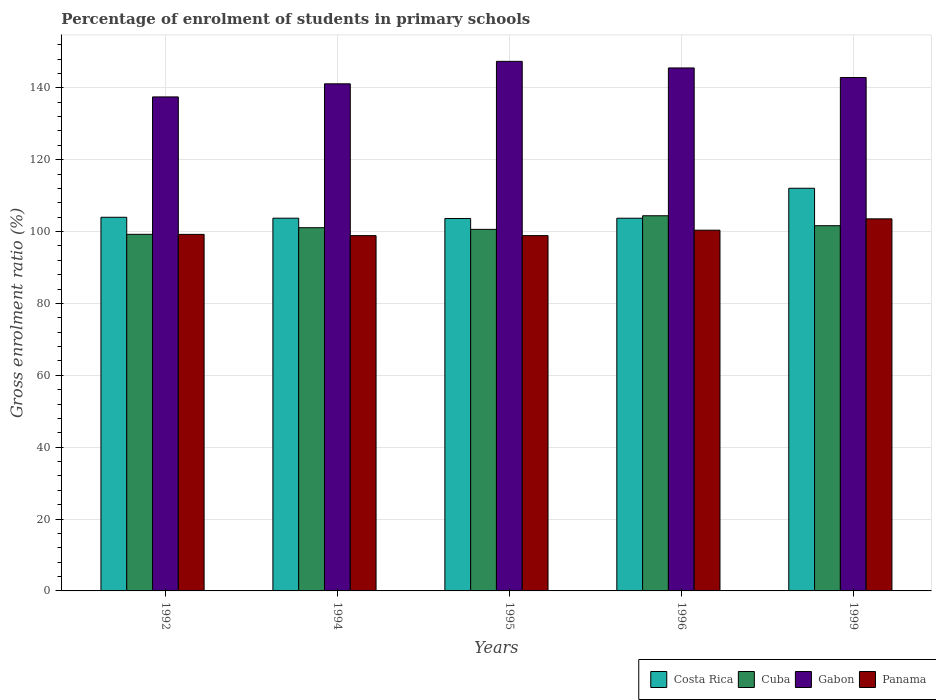How many groups of bars are there?
Give a very brief answer. 5. Are the number of bars per tick equal to the number of legend labels?
Your answer should be very brief. Yes. Are the number of bars on each tick of the X-axis equal?
Offer a terse response. Yes. How many bars are there on the 3rd tick from the left?
Make the answer very short. 4. What is the label of the 5th group of bars from the left?
Offer a very short reply. 1999. In how many cases, is the number of bars for a given year not equal to the number of legend labels?
Ensure brevity in your answer.  0. What is the percentage of students enrolled in primary schools in Costa Rica in 1996?
Keep it short and to the point. 103.72. Across all years, what is the maximum percentage of students enrolled in primary schools in Cuba?
Ensure brevity in your answer.  104.41. Across all years, what is the minimum percentage of students enrolled in primary schools in Panama?
Offer a terse response. 98.87. In which year was the percentage of students enrolled in primary schools in Panama maximum?
Your response must be concise. 1999. In which year was the percentage of students enrolled in primary schools in Panama minimum?
Give a very brief answer. 1994. What is the total percentage of students enrolled in primary schools in Costa Rica in the graph?
Make the answer very short. 527.13. What is the difference between the percentage of students enrolled in primary schools in Panama in 1994 and that in 1999?
Keep it short and to the point. -4.67. What is the difference between the percentage of students enrolled in primary schools in Cuba in 1996 and the percentage of students enrolled in primary schools in Costa Rica in 1995?
Your answer should be compact. 0.76. What is the average percentage of students enrolled in primary schools in Gabon per year?
Your answer should be very brief. 142.88. In the year 1995, what is the difference between the percentage of students enrolled in primary schools in Gabon and percentage of students enrolled in primary schools in Cuba?
Your answer should be very brief. 46.76. In how many years, is the percentage of students enrolled in primary schools in Costa Rica greater than 36 %?
Your answer should be compact. 5. What is the ratio of the percentage of students enrolled in primary schools in Panama in 1992 to that in 1999?
Your response must be concise. 0.96. What is the difference between the highest and the second highest percentage of students enrolled in primary schools in Cuba?
Provide a succinct answer. 2.77. What is the difference between the highest and the lowest percentage of students enrolled in primary schools in Gabon?
Keep it short and to the point. 9.9. Is the sum of the percentage of students enrolled in primary schools in Cuba in 1992 and 1996 greater than the maximum percentage of students enrolled in primary schools in Costa Rica across all years?
Your answer should be very brief. Yes. What does the 4th bar from the left in 1995 represents?
Offer a terse response. Panama. What does the 1st bar from the right in 1994 represents?
Provide a short and direct response. Panama. How many bars are there?
Your answer should be very brief. 20. Does the graph contain any zero values?
Offer a very short reply. No. Where does the legend appear in the graph?
Make the answer very short. Bottom right. How are the legend labels stacked?
Make the answer very short. Horizontal. What is the title of the graph?
Provide a succinct answer. Percentage of enrolment of students in primary schools. What is the label or title of the X-axis?
Keep it short and to the point. Years. What is the Gross enrolment ratio (%) in Costa Rica in 1992?
Offer a very short reply. 103.98. What is the Gross enrolment ratio (%) of Cuba in 1992?
Offer a terse response. 99.24. What is the Gross enrolment ratio (%) in Gabon in 1992?
Your answer should be compact. 137.48. What is the Gross enrolment ratio (%) of Panama in 1992?
Your response must be concise. 99.22. What is the Gross enrolment ratio (%) in Costa Rica in 1994?
Provide a short and direct response. 103.73. What is the Gross enrolment ratio (%) in Cuba in 1994?
Your answer should be very brief. 101.08. What is the Gross enrolment ratio (%) in Gabon in 1994?
Offer a very short reply. 141.12. What is the Gross enrolment ratio (%) of Panama in 1994?
Give a very brief answer. 98.87. What is the Gross enrolment ratio (%) in Costa Rica in 1995?
Your answer should be very brief. 103.64. What is the Gross enrolment ratio (%) of Cuba in 1995?
Your answer should be compact. 100.62. What is the Gross enrolment ratio (%) of Gabon in 1995?
Provide a succinct answer. 147.37. What is the Gross enrolment ratio (%) of Panama in 1995?
Provide a succinct answer. 98.88. What is the Gross enrolment ratio (%) of Costa Rica in 1996?
Give a very brief answer. 103.72. What is the Gross enrolment ratio (%) in Cuba in 1996?
Ensure brevity in your answer.  104.41. What is the Gross enrolment ratio (%) of Gabon in 1996?
Your response must be concise. 145.54. What is the Gross enrolment ratio (%) in Panama in 1996?
Your answer should be very brief. 100.39. What is the Gross enrolment ratio (%) of Costa Rica in 1999?
Give a very brief answer. 112.06. What is the Gross enrolment ratio (%) of Cuba in 1999?
Your answer should be compact. 101.63. What is the Gross enrolment ratio (%) in Gabon in 1999?
Keep it short and to the point. 142.87. What is the Gross enrolment ratio (%) in Panama in 1999?
Your answer should be compact. 103.54. Across all years, what is the maximum Gross enrolment ratio (%) in Costa Rica?
Keep it short and to the point. 112.06. Across all years, what is the maximum Gross enrolment ratio (%) in Cuba?
Your answer should be very brief. 104.41. Across all years, what is the maximum Gross enrolment ratio (%) of Gabon?
Your answer should be very brief. 147.37. Across all years, what is the maximum Gross enrolment ratio (%) of Panama?
Give a very brief answer. 103.54. Across all years, what is the minimum Gross enrolment ratio (%) of Costa Rica?
Your answer should be very brief. 103.64. Across all years, what is the minimum Gross enrolment ratio (%) in Cuba?
Your answer should be very brief. 99.24. Across all years, what is the minimum Gross enrolment ratio (%) of Gabon?
Offer a terse response. 137.48. Across all years, what is the minimum Gross enrolment ratio (%) in Panama?
Your response must be concise. 98.87. What is the total Gross enrolment ratio (%) in Costa Rica in the graph?
Offer a very short reply. 527.13. What is the total Gross enrolment ratio (%) in Cuba in the graph?
Your answer should be very brief. 506.97. What is the total Gross enrolment ratio (%) of Gabon in the graph?
Provide a succinct answer. 714.39. What is the total Gross enrolment ratio (%) in Panama in the graph?
Your answer should be compact. 500.91. What is the difference between the Gross enrolment ratio (%) of Costa Rica in 1992 and that in 1994?
Your response must be concise. 0.26. What is the difference between the Gross enrolment ratio (%) in Cuba in 1992 and that in 1994?
Provide a short and direct response. -1.84. What is the difference between the Gross enrolment ratio (%) in Gabon in 1992 and that in 1994?
Your answer should be compact. -3.65. What is the difference between the Gross enrolment ratio (%) in Panama in 1992 and that in 1994?
Provide a short and direct response. 0.35. What is the difference between the Gross enrolment ratio (%) of Costa Rica in 1992 and that in 1995?
Provide a succinct answer. 0.34. What is the difference between the Gross enrolment ratio (%) in Cuba in 1992 and that in 1995?
Give a very brief answer. -1.38. What is the difference between the Gross enrolment ratio (%) in Gabon in 1992 and that in 1995?
Your response must be concise. -9.9. What is the difference between the Gross enrolment ratio (%) in Panama in 1992 and that in 1995?
Offer a very short reply. 0.34. What is the difference between the Gross enrolment ratio (%) of Costa Rica in 1992 and that in 1996?
Your response must be concise. 0.27. What is the difference between the Gross enrolment ratio (%) in Cuba in 1992 and that in 1996?
Make the answer very short. -5.17. What is the difference between the Gross enrolment ratio (%) in Gabon in 1992 and that in 1996?
Give a very brief answer. -8.06. What is the difference between the Gross enrolment ratio (%) in Panama in 1992 and that in 1996?
Keep it short and to the point. -1.17. What is the difference between the Gross enrolment ratio (%) of Costa Rica in 1992 and that in 1999?
Offer a very short reply. -8.07. What is the difference between the Gross enrolment ratio (%) of Cuba in 1992 and that in 1999?
Your answer should be compact. -2.4. What is the difference between the Gross enrolment ratio (%) in Gabon in 1992 and that in 1999?
Ensure brevity in your answer.  -5.4. What is the difference between the Gross enrolment ratio (%) of Panama in 1992 and that in 1999?
Ensure brevity in your answer.  -4.32. What is the difference between the Gross enrolment ratio (%) in Costa Rica in 1994 and that in 1995?
Offer a terse response. 0.08. What is the difference between the Gross enrolment ratio (%) of Cuba in 1994 and that in 1995?
Give a very brief answer. 0.46. What is the difference between the Gross enrolment ratio (%) of Gabon in 1994 and that in 1995?
Provide a succinct answer. -6.25. What is the difference between the Gross enrolment ratio (%) in Panama in 1994 and that in 1995?
Make the answer very short. -0.01. What is the difference between the Gross enrolment ratio (%) of Costa Rica in 1994 and that in 1996?
Offer a very short reply. 0.01. What is the difference between the Gross enrolment ratio (%) of Cuba in 1994 and that in 1996?
Your answer should be compact. -3.33. What is the difference between the Gross enrolment ratio (%) of Gabon in 1994 and that in 1996?
Your answer should be very brief. -4.42. What is the difference between the Gross enrolment ratio (%) in Panama in 1994 and that in 1996?
Make the answer very short. -1.51. What is the difference between the Gross enrolment ratio (%) of Costa Rica in 1994 and that in 1999?
Offer a very short reply. -8.33. What is the difference between the Gross enrolment ratio (%) in Cuba in 1994 and that in 1999?
Ensure brevity in your answer.  -0.56. What is the difference between the Gross enrolment ratio (%) of Gabon in 1994 and that in 1999?
Your answer should be very brief. -1.75. What is the difference between the Gross enrolment ratio (%) in Panama in 1994 and that in 1999?
Make the answer very short. -4.67. What is the difference between the Gross enrolment ratio (%) in Costa Rica in 1995 and that in 1996?
Keep it short and to the point. -0.08. What is the difference between the Gross enrolment ratio (%) of Cuba in 1995 and that in 1996?
Give a very brief answer. -3.79. What is the difference between the Gross enrolment ratio (%) of Gabon in 1995 and that in 1996?
Give a very brief answer. 1.83. What is the difference between the Gross enrolment ratio (%) of Panama in 1995 and that in 1996?
Your answer should be compact. -1.51. What is the difference between the Gross enrolment ratio (%) of Costa Rica in 1995 and that in 1999?
Your answer should be compact. -8.42. What is the difference between the Gross enrolment ratio (%) in Cuba in 1995 and that in 1999?
Offer a terse response. -1.02. What is the difference between the Gross enrolment ratio (%) of Gabon in 1995 and that in 1999?
Provide a short and direct response. 4.5. What is the difference between the Gross enrolment ratio (%) of Panama in 1995 and that in 1999?
Offer a terse response. -4.66. What is the difference between the Gross enrolment ratio (%) of Costa Rica in 1996 and that in 1999?
Offer a terse response. -8.34. What is the difference between the Gross enrolment ratio (%) in Cuba in 1996 and that in 1999?
Your response must be concise. 2.77. What is the difference between the Gross enrolment ratio (%) in Gabon in 1996 and that in 1999?
Give a very brief answer. 2.67. What is the difference between the Gross enrolment ratio (%) in Panama in 1996 and that in 1999?
Your answer should be compact. -3.15. What is the difference between the Gross enrolment ratio (%) of Costa Rica in 1992 and the Gross enrolment ratio (%) of Cuba in 1994?
Offer a very short reply. 2.91. What is the difference between the Gross enrolment ratio (%) of Costa Rica in 1992 and the Gross enrolment ratio (%) of Gabon in 1994?
Your answer should be very brief. -37.14. What is the difference between the Gross enrolment ratio (%) in Costa Rica in 1992 and the Gross enrolment ratio (%) in Panama in 1994?
Offer a terse response. 5.11. What is the difference between the Gross enrolment ratio (%) of Cuba in 1992 and the Gross enrolment ratio (%) of Gabon in 1994?
Offer a terse response. -41.89. What is the difference between the Gross enrolment ratio (%) in Cuba in 1992 and the Gross enrolment ratio (%) in Panama in 1994?
Your answer should be compact. 0.36. What is the difference between the Gross enrolment ratio (%) in Gabon in 1992 and the Gross enrolment ratio (%) in Panama in 1994?
Make the answer very short. 38.6. What is the difference between the Gross enrolment ratio (%) in Costa Rica in 1992 and the Gross enrolment ratio (%) in Cuba in 1995?
Make the answer very short. 3.37. What is the difference between the Gross enrolment ratio (%) of Costa Rica in 1992 and the Gross enrolment ratio (%) of Gabon in 1995?
Your answer should be compact. -43.39. What is the difference between the Gross enrolment ratio (%) in Costa Rica in 1992 and the Gross enrolment ratio (%) in Panama in 1995?
Offer a very short reply. 5.1. What is the difference between the Gross enrolment ratio (%) of Cuba in 1992 and the Gross enrolment ratio (%) of Gabon in 1995?
Your answer should be very brief. -48.14. What is the difference between the Gross enrolment ratio (%) of Cuba in 1992 and the Gross enrolment ratio (%) of Panama in 1995?
Ensure brevity in your answer.  0.36. What is the difference between the Gross enrolment ratio (%) of Gabon in 1992 and the Gross enrolment ratio (%) of Panama in 1995?
Your response must be concise. 38.6. What is the difference between the Gross enrolment ratio (%) of Costa Rica in 1992 and the Gross enrolment ratio (%) of Cuba in 1996?
Your answer should be compact. -0.42. What is the difference between the Gross enrolment ratio (%) in Costa Rica in 1992 and the Gross enrolment ratio (%) in Gabon in 1996?
Offer a terse response. -41.56. What is the difference between the Gross enrolment ratio (%) in Costa Rica in 1992 and the Gross enrolment ratio (%) in Panama in 1996?
Offer a terse response. 3.6. What is the difference between the Gross enrolment ratio (%) of Cuba in 1992 and the Gross enrolment ratio (%) of Gabon in 1996?
Provide a succinct answer. -46.3. What is the difference between the Gross enrolment ratio (%) in Cuba in 1992 and the Gross enrolment ratio (%) in Panama in 1996?
Offer a terse response. -1.15. What is the difference between the Gross enrolment ratio (%) of Gabon in 1992 and the Gross enrolment ratio (%) of Panama in 1996?
Offer a terse response. 37.09. What is the difference between the Gross enrolment ratio (%) of Costa Rica in 1992 and the Gross enrolment ratio (%) of Cuba in 1999?
Ensure brevity in your answer.  2.35. What is the difference between the Gross enrolment ratio (%) in Costa Rica in 1992 and the Gross enrolment ratio (%) in Gabon in 1999?
Give a very brief answer. -38.89. What is the difference between the Gross enrolment ratio (%) in Costa Rica in 1992 and the Gross enrolment ratio (%) in Panama in 1999?
Offer a terse response. 0.44. What is the difference between the Gross enrolment ratio (%) in Cuba in 1992 and the Gross enrolment ratio (%) in Gabon in 1999?
Your response must be concise. -43.64. What is the difference between the Gross enrolment ratio (%) in Cuba in 1992 and the Gross enrolment ratio (%) in Panama in 1999?
Offer a very short reply. -4.3. What is the difference between the Gross enrolment ratio (%) in Gabon in 1992 and the Gross enrolment ratio (%) in Panama in 1999?
Offer a very short reply. 33.93. What is the difference between the Gross enrolment ratio (%) in Costa Rica in 1994 and the Gross enrolment ratio (%) in Cuba in 1995?
Provide a succinct answer. 3.11. What is the difference between the Gross enrolment ratio (%) of Costa Rica in 1994 and the Gross enrolment ratio (%) of Gabon in 1995?
Your response must be concise. -43.65. What is the difference between the Gross enrolment ratio (%) in Costa Rica in 1994 and the Gross enrolment ratio (%) in Panama in 1995?
Your answer should be very brief. 4.85. What is the difference between the Gross enrolment ratio (%) of Cuba in 1994 and the Gross enrolment ratio (%) of Gabon in 1995?
Ensure brevity in your answer.  -46.3. What is the difference between the Gross enrolment ratio (%) in Cuba in 1994 and the Gross enrolment ratio (%) in Panama in 1995?
Provide a short and direct response. 2.2. What is the difference between the Gross enrolment ratio (%) in Gabon in 1994 and the Gross enrolment ratio (%) in Panama in 1995?
Your response must be concise. 42.24. What is the difference between the Gross enrolment ratio (%) of Costa Rica in 1994 and the Gross enrolment ratio (%) of Cuba in 1996?
Give a very brief answer. -0.68. What is the difference between the Gross enrolment ratio (%) in Costa Rica in 1994 and the Gross enrolment ratio (%) in Gabon in 1996?
Offer a very short reply. -41.81. What is the difference between the Gross enrolment ratio (%) of Costa Rica in 1994 and the Gross enrolment ratio (%) of Panama in 1996?
Make the answer very short. 3.34. What is the difference between the Gross enrolment ratio (%) in Cuba in 1994 and the Gross enrolment ratio (%) in Gabon in 1996?
Offer a very short reply. -44.46. What is the difference between the Gross enrolment ratio (%) of Cuba in 1994 and the Gross enrolment ratio (%) of Panama in 1996?
Ensure brevity in your answer.  0.69. What is the difference between the Gross enrolment ratio (%) of Gabon in 1994 and the Gross enrolment ratio (%) of Panama in 1996?
Offer a very short reply. 40.73. What is the difference between the Gross enrolment ratio (%) in Costa Rica in 1994 and the Gross enrolment ratio (%) in Cuba in 1999?
Provide a succinct answer. 2.09. What is the difference between the Gross enrolment ratio (%) of Costa Rica in 1994 and the Gross enrolment ratio (%) of Gabon in 1999?
Keep it short and to the point. -39.15. What is the difference between the Gross enrolment ratio (%) in Costa Rica in 1994 and the Gross enrolment ratio (%) in Panama in 1999?
Ensure brevity in your answer.  0.18. What is the difference between the Gross enrolment ratio (%) of Cuba in 1994 and the Gross enrolment ratio (%) of Gabon in 1999?
Your answer should be compact. -41.8. What is the difference between the Gross enrolment ratio (%) in Cuba in 1994 and the Gross enrolment ratio (%) in Panama in 1999?
Offer a terse response. -2.47. What is the difference between the Gross enrolment ratio (%) in Gabon in 1994 and the Gross enrolment ratio (%) in Panama in 1999?
Offer a very short reply. 37.58. What is the difference between the Gross enrolment ratio (%) in Costa Rica in 1995 and the Gross enrolment ratio (%) in Cuba in 1996?
Offer a very short reply. -0.76. What is the difference between the Gross enrolment ratio (%) of Costa Rica in 1995 and the Gross enrolment ratio (%) of Gabon in 1996?
Your answer should be very brief. -41.9. What is the difference between the Gross enrolment ratio (%) in Costa Rica in 1995 and the Gross enrolment ratio (%) in Panama in 1996?
Ensure brevity in your answer.  3.25. What is the difference between the Gross enrolment ratio (%) in Cuba in 1995 and the Gross enrolment ratio (%) in Gabon in 1996?
Provide a succinct answer. -44.92. What is the difference between the Gross enrolment ratio (%) of Cuba in 1995 and the Gross enrolment ratio (%) of Panama in 1996?
Offer a very short reply. 0.23. What is the difference between the Gross enrolment ratio (%) in Gabon in 1995 and the Gross enrolment ratio (%) in Panama in 1996?
Your answer should be very brief. 46.99. What is the difference between the Gross enrolment ratio (%) in Costa Rica in 1995 and the Gross enrolment ratio (%) in Cuba in 1999?
Provide a short and direct response. 2.01. What is the difference between the Gross enrolment ratio (%) of Costa Rica in 1995 and the Gross enrolment ratio (%) of Gabon in 1999?
Your response must be concise. -39.23. What is the difference between the Gross enrolment ratio (%) of Cuba in 1995 and the Gross enrolment ratio (%) of Gabon in 1999?
Provide a succinct answer. -42.26. What is the difference between the Gross enrolment ratio (%) in Cuba in 1995 and the Gross enrolment ratio (%) in Panama in 1999?
Your answer should be compact. -2.92. What is the difference between the Gross enrolment ratio (%) in Gabon in 1995 and the Gross enrolment ratio (%) in Panama in 1999?
Offer a terse response. 43.83. What is the difference between the Gross enrolment ratio (%) in Costa Rica in 1996 and the Gross enrolment ratio (%) in Cuba in 1999?
Offer a terse response. 2.09. What is the difference between the Gross enrolment ratio (%) of Costa Rica in 1996 and the Gross enrolment ratio (%) of Gabon in 1999?
Make the answer very short. -39.16. What is the difference between the Gross enrolment ratio (%) in Costa Rica in 1996 and the Gross enrolment ratio (%) in Panama in 1999?
Make the answer very short. 0.18. What is the difference between the Gross enrolment ratio (%) in Cuba in 1996 and the Gross enrolment ratio (%) in Gabon in 1999?
Ensure brevity in your answer.  -38.47. What is the difference between the Gross enrolment ratio (%) in Cuba in 1996 and the Gross enrolment ratio (%) in Panama in 1999?
Offer a terse response. 0.86. What is the difference between the Gross enrolment ratio (%) in Gabon in 1996 and the Gross enrolment ratio (%) in Panama in 1999?
Your answer should be very brief. 42. What is the average Gross enrolment ratio (%) of Costa Rica per year?
Provide a short and direct response. 105.43. What is the average Gross enrolment ratio (%) of Cuba per year?
Your response must be concise. 101.39. What is the average Gross enrolment ratio (%) in Gabon per year?
Offer a very short reply. 142.88. What is the average Gross enrolment ratio (%) of Panama per year?
Offer a terse response. 100.18. In the year 1992, what is the difference between the Gross enrolment ratio (%) of Costa Rica and Gross enrolment ratio (%) of Cuba?
Give a very brief answer. 4.75. In the year 1992, what is the difference between the Gross enrolment ratio (%) in Costa Rica and Gross enrolment ratio (%) in Gabon?
Give a very brief answer. -33.49. In the year 1992, what is the difference between the Gross enrolment ratio (%) in Costa Rica and Gross enrolment ratio (%) in Panama?
Your answer should be compact. 4.76. In the year 1992, what is the difference between the Gross enrolment ratio (%) in Cuba and Gross enrolment ratio (%) in Gabon?
Keep it short and to the point. -38.24. In the year 1992, what is the difference between the Gross enrolment ratio (%) of Cuba and Gross enrolment ratio (%) of Panama?
Provide a succinct answer. 0.02. In the year 1992, what is the difference between the Gross enrolment ratio (%) of Gabon and Gross enrolment ratio (%) of Panama?
Offer a terse response. 38.26. In the year 1994, what is the difference between the Gross enrolment ratio (%) of Costa Rica and Gross enrolment ratio (%) of Cuba?
Offer a very short reply. 2.65. In the year 1994, what is the difference between the Gross enrolment ratio (%) in Costa Rica and Gross enrolment ratio (%) in Gabon?
Provide a short and direct response. -37.4. In the year 1994, what is the difference between the Gross enrolment ratio (%) in Costa Rica and Gross enrolment ratio (%) in Panama?
Give a very brief answer. 4.85. In the year 1994, what is the difference between the Gross enrolment ratio (%) in Cuba and Gross enrolment ratio (%) in Gabon?
Give a very brief answer. -40.05. In the year 1994, what is the difference between the Gross enrolment ratio (%) in Cuba and Gross enrolment ratio (%) in Panama?
Your answer should be compact. 2.2. In the year 1994, what is the difference between the Gross enrolment ratio (%) of Gabon and Gross enrolment ratio (%) of Panama?
Give a very brief answer. 42.25. In the year 1995, what is the difference between the Gross enrolment ratio (%) of Costa Rica and Gross enrolment ratio (%) of Cuba?
Your answer should be compact. 3.02. In the year 1995, what is the difference between the Gross enrolment ratio (%) of Costa Rica and Gross enrolment ratio (%) of Gabon?
Provide a short and direct response. -43.73. In the year 1995, what is the difference between the Gross enrolment ratio (%) of Costa Rica and Gross enrolment ratio (%) of Panama?
Make the answer very short. 4.76. In the year 1995, what is the difference between the Gross enrolment ratio (%) of Cuba and Gross enrolment ratio (%) of Gabon?
Make the answer very short. -46.76. In the year 1995, what is the difference between the Gross enrolment ratio (%) of Cuba and Gross enrolment ratio (%) of Panama?
Offer a very short reply. 1.74. In the year 1995, what is the difference between the Gross enrolment ratio (%) in Gabon and Gross enrolment ratio (%) in Panama?
Keep it short and to the point. 48.49. In the year 1996, what is the difference between the Gross enrolment ratio (%) in Costa Rica and Gross enrolment ratio (%) in Cuba?
Make the answer very short. -0.69. In the year 1996, what is the difference between the Gross enrolment ratio (%) of Costa Rica and Gross enrolment ratio (%) of Gabon?
Your response must be concise. -41.82. In the year 1996, what is the difference between the Gross enrolment ratio (%) of Costa Rica and Gross enrolment ratio (%) of Panama?
Offer a terse response. 3.33. In the year 1996, what is the difference between the Gross enrolment ratio (%) in Cuba and Gross enrolment ratio (%) in Gabon?
Provide a short and direct response. -41.13. In the year 1996, what is the difference between the Gross enrolment ratio (%) in Cuba and Gross enrolment ratio (%) in Panama?
Your response must be concise. 4.02. In the year 1996, what is the difference between the Gross enrolment ratio (%) in Gabon and Gross enrolment ratio (%) in Panama?
Ensure brevity in your answer.  45.15. In the year 1999, what is the difference between the Gross enrolment ratio (%) in Costa Rica and Gross enrolment ratio (%) in Cuba?
Your answer should be very brief. 10.43. In the year 1999, what is the difference between the Gross enrolment ratio (%) in Costa Rica and Gross enrolment ratio (%) in Gabon?
Your answer should be very brief. -30.82. In the year 1999, what is the difference between the Gross enrolment ratio (%) in Costa Rica and Gross enrolment ratio (%) in Panama?
Your answer should be very brief. 8.52. In the year 1999, what is the difference between the Gross enrolment ratio (%) in Cuba and Gross enrolment ratio (%) in Gabon?
Give a very brief answer. -41.24. In the year 1999, what is the difference between the Gross enrolment ratio (%) of Cuba and Gross enrolment ratio (%) of Panama?
Make the answer very short. -1.91. In the year 1999, what is the difference between the Gross enrolment ratio (%) in Gabon and Gross enrolment ratio (%) in Panama?
Keep it short and to the point. 39.33. What is the ratio of the Gross enrolment ratio (%) of Costa Rica in 1992 to that in 1994?
Your response must be concise. 1. What is the ratio of the Gross enrolment ratio (%) of Cuba in 1992 to that in 1994?
Make the answer very short. 0.98. What is the ratio of the Gross enrolment ratio (%) in Gabon in 1992 to that in 1994?
Offer a very short reply. 0.97. What is the ratio of the Gross enrolment ratio (%) in Costa Rica in 1992 to that in 1995?
Your answer should be compact. 1. What is the ratio of the Gross enrolment ratio (%) in Cuba in 1992 to that in 1995?
Keep it short and to the point. 0.99. What is the ratio of the Gross enrolment ratio (%) of Gabon in 1992 to that in 1995?
Your answer should be compact. 0.93. What is the ratio of the Gross enrolment ratio (%) in Panama in 1992 to that in 1995?
Give a very brief answer. 1. What is the ratio of the Gross enrolment ratio (%) of Cuba in 1992 to that in 1996?
Provide a succinct answer. 0.95. What is the ratio of the Gross enrolment ratio (%) of Gabon in 1992 to that in 1996?
Provide a short and direct response. 0.94. What is the ratio of the Gross enrolment ratio (%) of Panama in 1992 to that in 1996?
Offer a very short reply. 0.99. What is the ratio of the Gross enrolment ratio (%) of Costa Rica in 1992 to that in 1999?
Offer a terse response. 0.93. What is the ratio of the Gross enrolment ratio (%) of Cuba in 1992 to that in 1999?
Your answer should be compact. 0.98. What is the ratio of the Gross enrolment ratio (%) in Gabon in 1992 to that in 1999?
Ensure brevity in your answer.  0.96. What is the ratio of the Gross enrolment ratio (%) in Costa Rica in 1994 to that in 1995?
Your answer should be compact. 1. What is the ratio of the Gross enrolment ratio (%) of Cuba in 1994 to that in 1995?
Offer a terse response. 1. What is the ratio of the Gross enrolment ratio (%) of Gabon in 1994 to that in 1995?
Give a very brief answer. 0.96. What is the ratio of the Gross enrolment ratio (%) of Panama in 1994 to that in 1995?
Provide a succinct answer. 1. What is the ratio of the Gross enrolment ratio (%) of Costa Rica in 1994 to that in 1996?
Your answer should be very brief. 1. What is the ratio of the Gross enrolment ratio (%) of Cuba in 1994 to that in 1996?
Provide a short and direct response. 0.97. What is the ratio of the Gross enrolment ratio (%) of Gabon in 1994 to that in 1996?
Offer a terse response. 0.97. What is the ratio of the Gross enrolment ratio (%) in Panama in 1994 to that in 1996?
Make the answer very short. 0.98. What is the ratio of the Gross enrolment ratio (%) of Costa Rica in 1994 to that in 1999?
Offer a terse response. 0.93. What is the ratio of the Gross enrolment ratio (%) of Cuba in 1994 to that in 1999?
Your response must be concise. 0.99. What is the ratio of the Gross enrolment ratio (%) of Panama in 1994 to that in 1999?
Your answer should be very brief. 0.95. What is the ratio of the Gross enrolment ratio (%) of Costa Rica in 1995 to that in 1996?
Your response must be concise. 1. What is the ratio of the Gross enrolment ratio (%) of Cuba in 1995 to that in 1996?
Offer a very short reply. 0.96. What is the ratio of the Gross enrolment ratio (%) in Gabon in 1995 to that in 1996?
Give a very brief answer. 1.01. What is the ratio of the Gross enrolment ratio (%) of Panama in 1995 to that in 1996?
Make the answer very short. 0.98. What is the ratio of the Gross enrolment ratio (%) of Costa Rica in 1995 to that in 1999?
Offer a terse response. 0.92. What is the ratio of the Gross enrolment ratio (%) of Cuba in 1995 to that in 1999?
Provide a short and direct response. 0.99. What is the ratio of the Gross enrolment ratio (%) in Gabon in 1995 to that in 1999?
Ensure brevity in your answer.  1.03. What is the ratio of the Gross enrolment ratio (%) in Panama in 1995 to that in 1999?
Ensure brevity in your answer.  0.95. What is the ratio of the Gross enrolment ratio (%) of Costa Rica in 1996 to that in 1999?
Keep it short and to the point. 0.93. What is the ratio of the Gross enrolment ratio (%) in Cuba in 1996 to that in 1999?
Offer a very short reply. 1.03. What is the ratio of the Gross enrolment ratio (%) of Gabon in 1996 to that in 1999?
Offer a very short reply. 1.02. What is the ratio of the Gross enrolment ratio (%) in Panama in 1996 to that in 1999?
Keep it short and to the point. 0.97. What is the difference between the highest and the second highest Gross enrolment ratio (%) in Costa Rica?
Offer a very short reply. 8.07. What is the difference between the highest and the second highest Gross enrolment ratio (%) of Cuba?
Provide a short and direct response. 2.77. What is the difference between the highest and the second highest Gross enrolment ratio (%) in Gabon?
Your answer should be compact. 1.83. What is the difference between the highest and the second highest Gross enrolment ratio (%) in Panama?
Make the answer very short. 3.15. What is the difference between the highest and the lowest Gross enrolment ratio (%) of Costa Rica?
Your response must be concise. 8.42. What is the difference between the highest and the lowest Gross enrolment ratio (%) of Cuba?
Your response must be concise. 5.17. What is the difference between the highest and the lowest Gross enrolment ratio (%) in Gabon?
Your response must be concise. 9.9. What is the difference between the highest and the lowest Gross enrolment ratio (%) of Panama?
Provide a succinct answer. 4.67. 